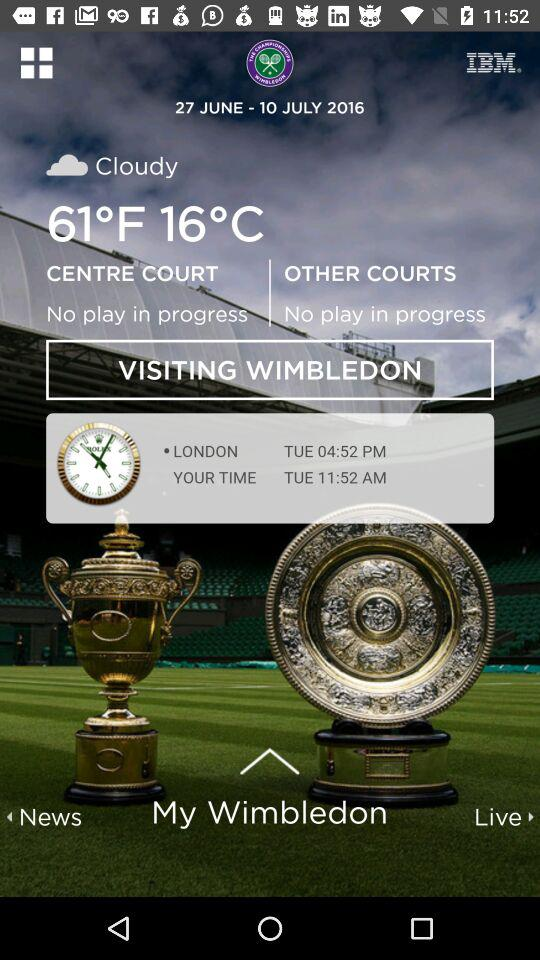How's the weather? The weather is cloudy. 